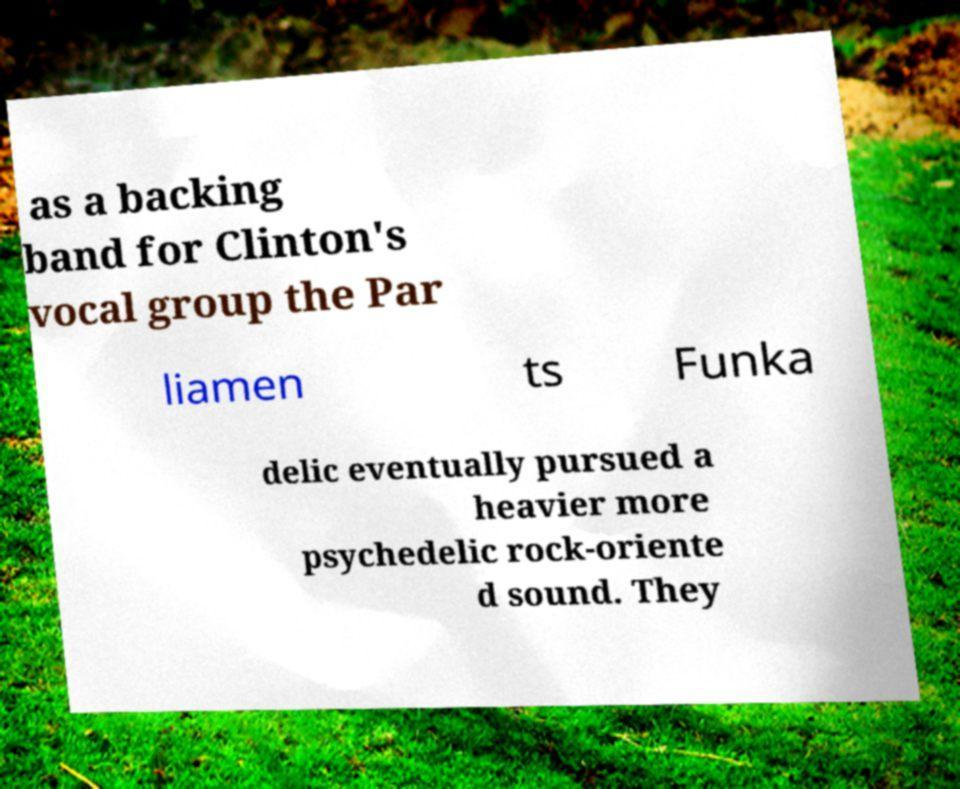Can you read and provide the text displayed in the image?This photo seems to have some interesting text. Can you extract and type it out for me? as a backing band for Clinton's vocal group the Par liamen ts Funka delic eventually pursued a heavier more psychedelic rock-oriente d sound. They 